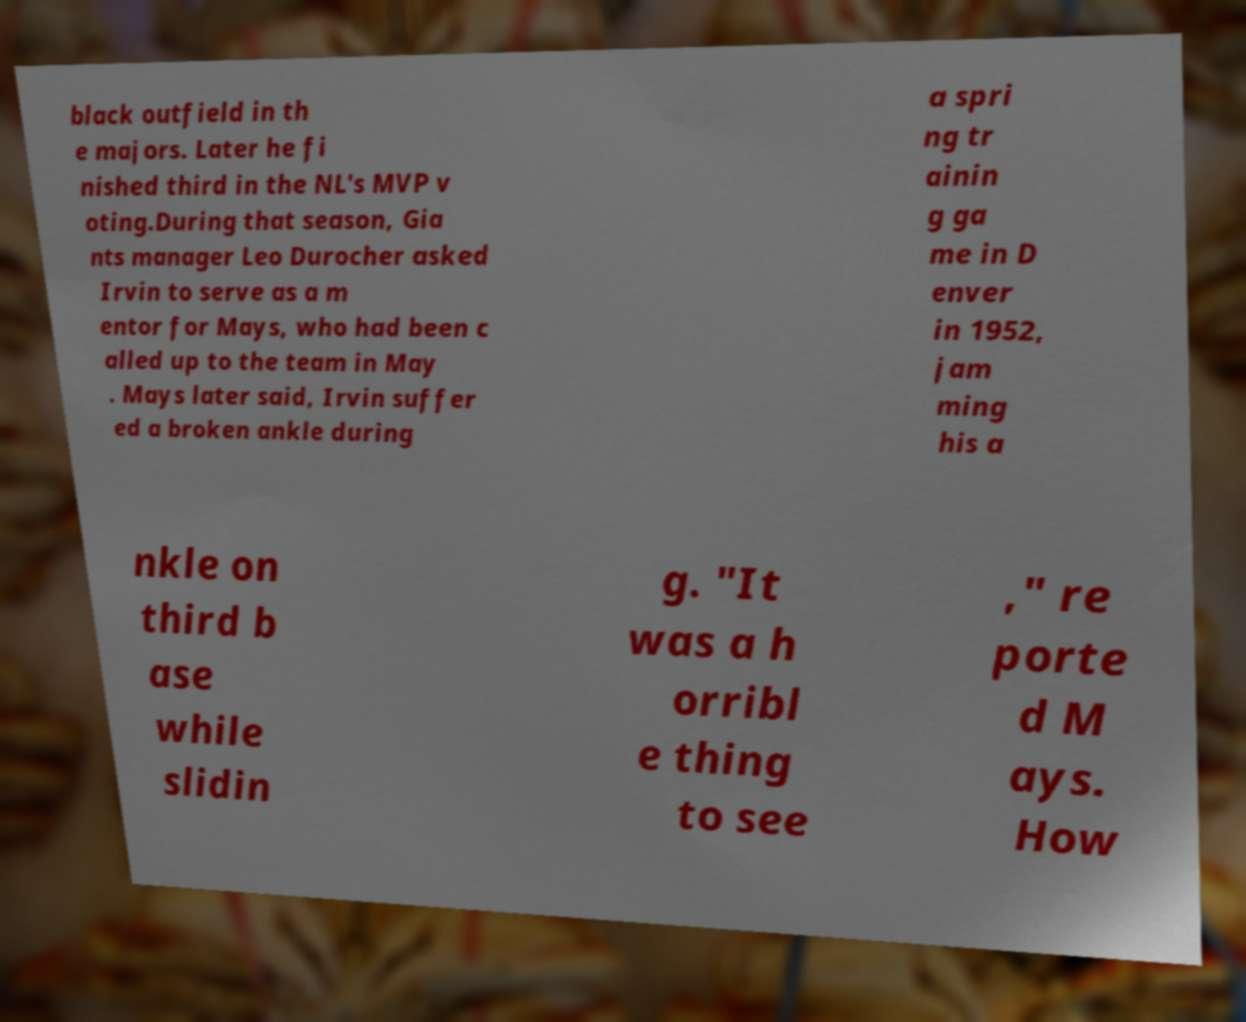Could you assist in decoding the text presented in this image and type it out clearly? black outfield in th e majors. Later he fi nished third in the NL's MVP v oting.During that season, Gia nts manager Leo Durocher asked Irvin to serve as a m entor for Mays, who had been c alled up to the team in May . Mays later said, Irvin suffer ed a broken ankle during a spri ng tr ainin g ga me in D enver in 1952, jam ming his a nkle on third b ase while slidin g. "It was a h orribl e thing to see ," re porte d M ays. How 